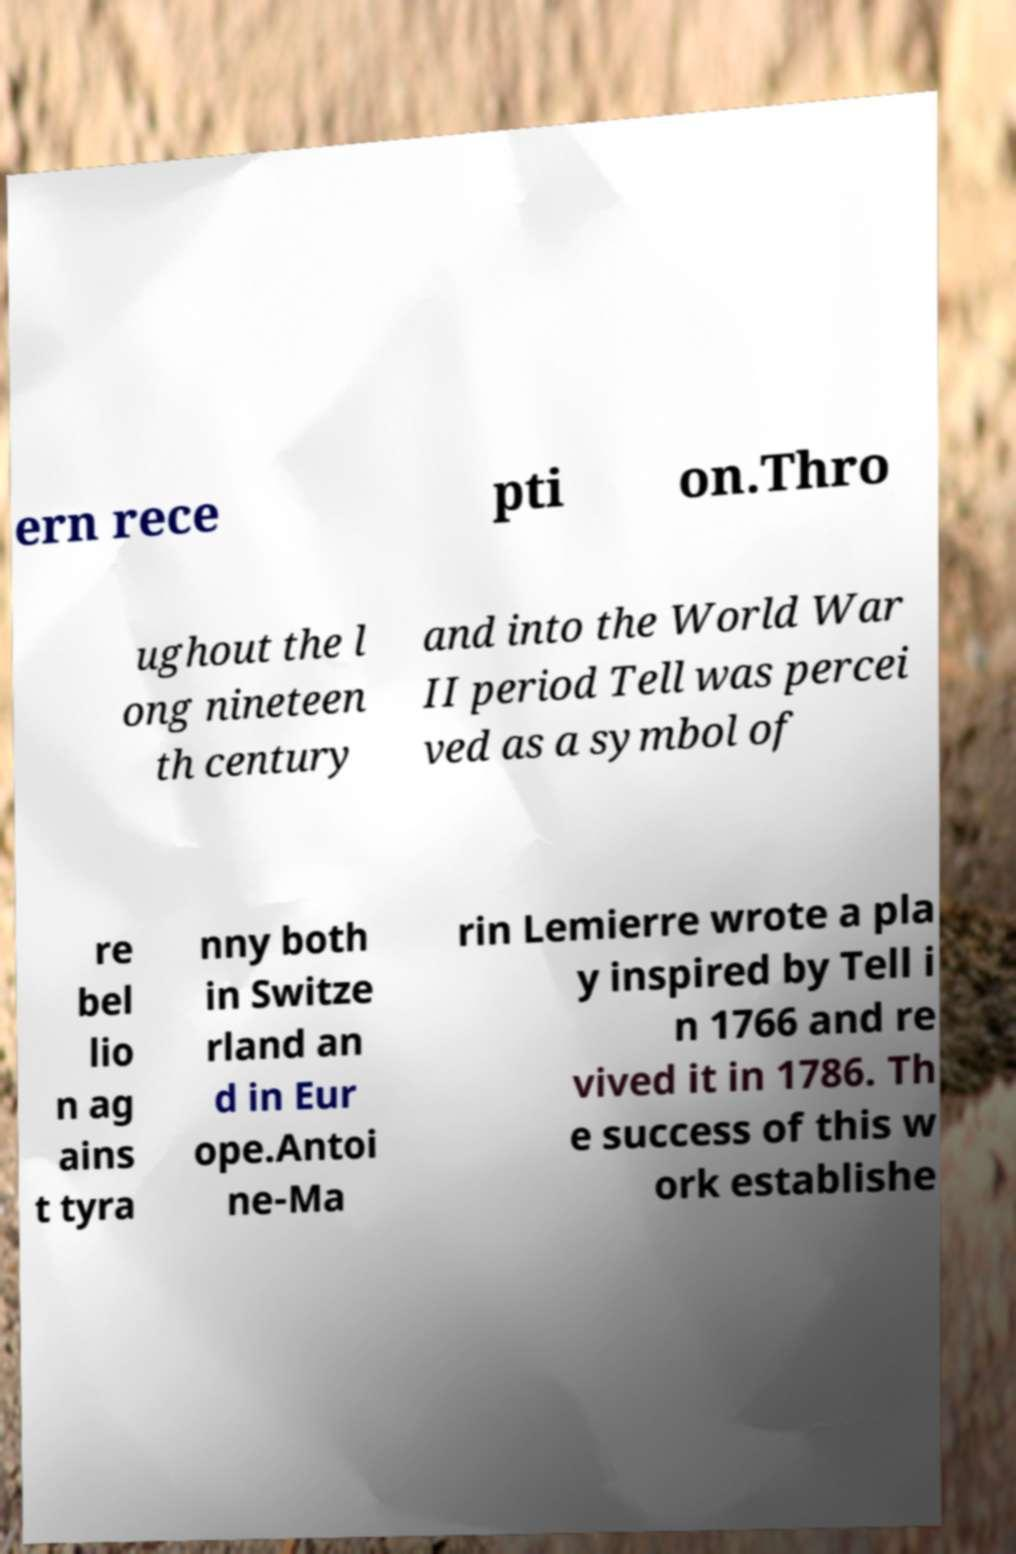I need the written content from this picture converted into text. Can you do that? ern rece pti on.Thro ughout the l ong nineteen th century and into the World War II period Tell was percei ved as a symbol of re bel lio n ag ains t tyra nny both in Switze rland an d in Eur ope.Antoi ne-Ma rin Lemierre wrote a pla y inspired by Tell i n 1766 and re vived it in 1786. Th e success of this w ork establishe 